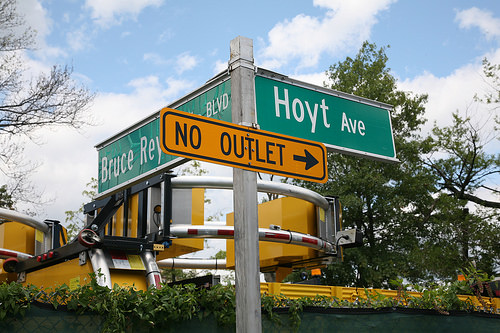<image>
Is there a sign in front of the tree? Yes. The sign is positioned in front of the tree, appearing closer to the camera viewpoint. 